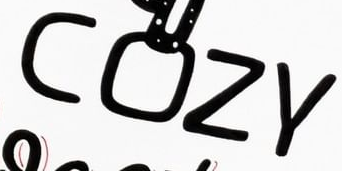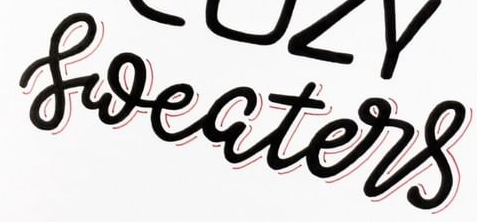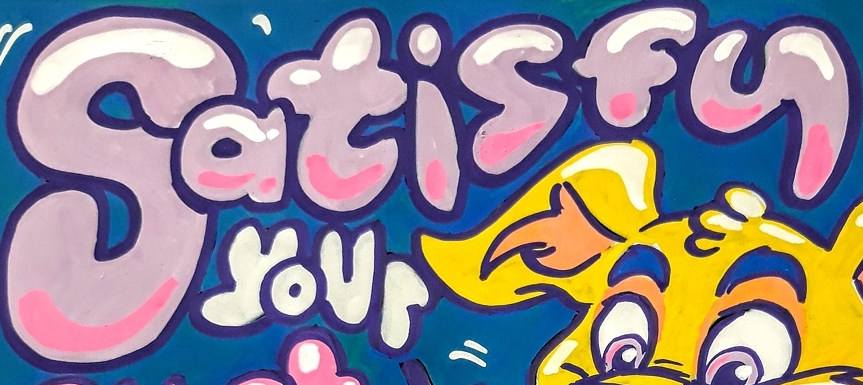What text is displayed in these images sequentially, separated by a semicolon? COZY; sweaters; Satisfy 